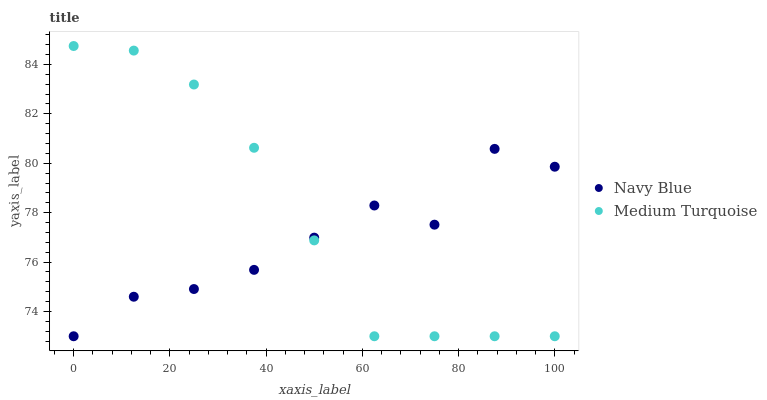Does Navy Blue have the minimum area under the curve?
Answer yes or no. Yes. Does Medium Turquoise have the maximum area under the curve?
Answer yes or no. Yes. Does Medium Turquoise have the minimum area under the curve?
Answer yes or no. No. Is Medium Turquoise the smoothest?
Answer yes or no. Yes. Is Navy Blue the roughest?
Answer yes or no. Yes. Is Medium Turquoise the roughest?
Answer yes or no. No. Does Navy Blue have the lowest value?
Answer yes or no. Yes. Does Medium Turquoise have the highest value?
Answer yes or no. Yes. Does Navy Blue intersect Medium Turquoise?
Answer yes or no. Yes. Is Navy Blue less than Medium Turquoise?
Answer yes or no. No. Is Navy Blue greater than Medium Turquoise?
Answer yes or no. No. 